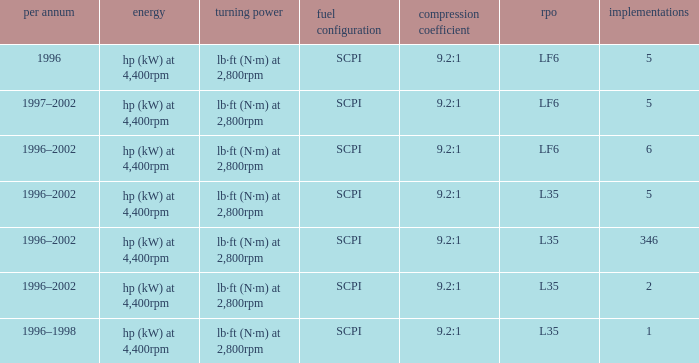What are the torque characteristics of the model with 346 applications? Lb·ft (n·m) at 2,800rpm. 